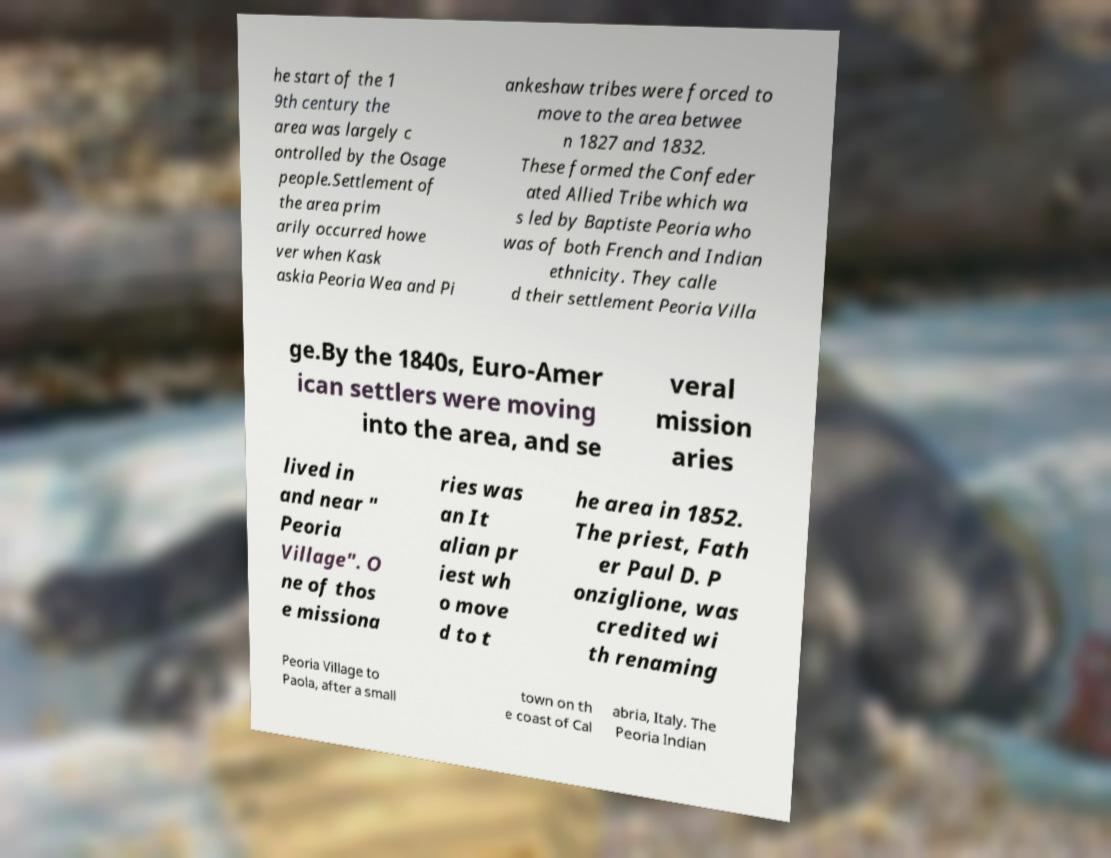Can you read and provide the text displayed in the image?This photo seems to have some interesting text. Can you extract and type it out for me? he start of the 1 9th century the area was largely c ontrolled by the Osage people.Settlement of the area prim arily occurred howe ver when Kask askia Peoria Wea and Pi ankeshaw tribes were forced to move to the area betwee n 1827 and 1832. These formed the Confeder ated Allied Tribe which wa s led by Baptiste Peoria who was of both French and Indian ethnicity. They calle d their settlement Peoria Villa ge.By the 1840s, Euro-Amer ican settlers were moving into the area, and se veral mission aries lived in and near " Peoria Village". O ne of thos e missiona ries was an It alian pr iest wh o move d to t he area in 1852. The priest, Fath er Paul D. P onziglione, was credited wi th renaming Peoria Village to Paola, after a small town on th e coast of Cal abria, Italy. The Peoria Indian 